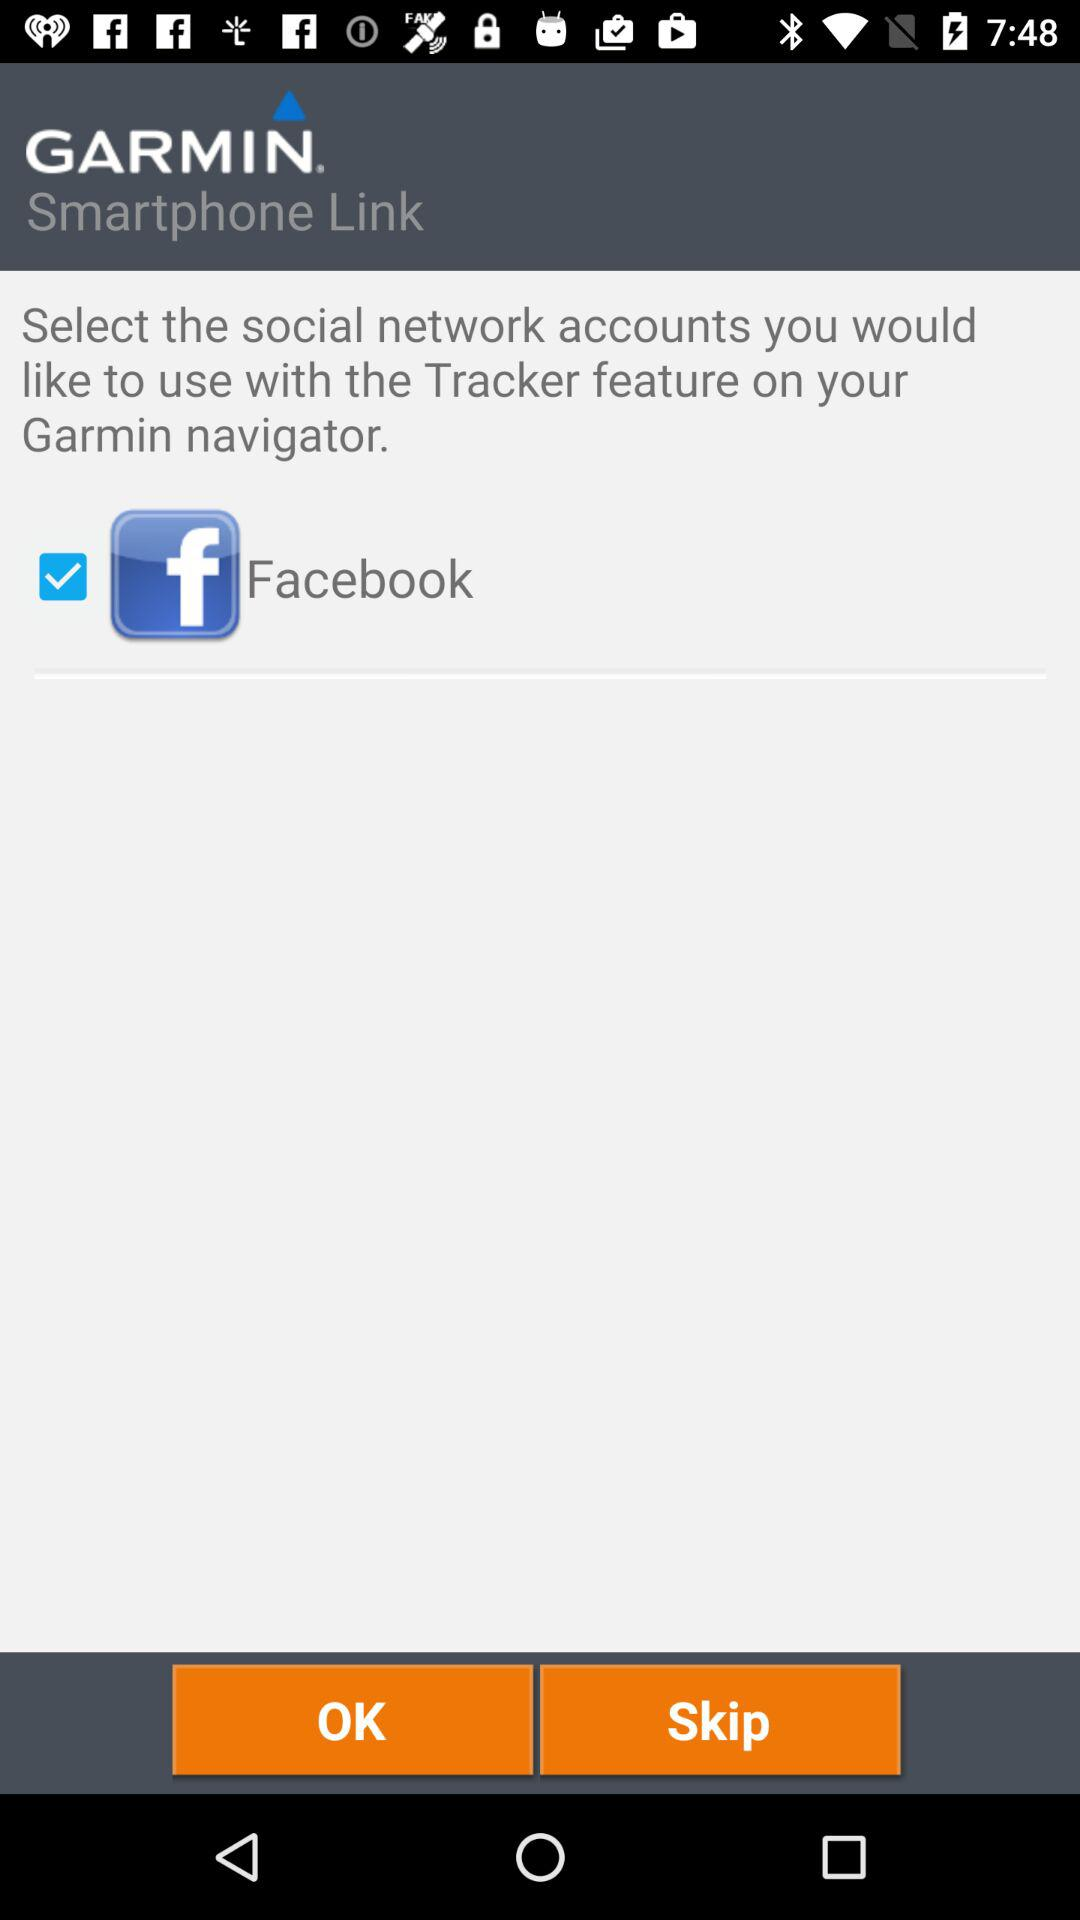What is the name of the application? The name of the application is "GARMIN". 